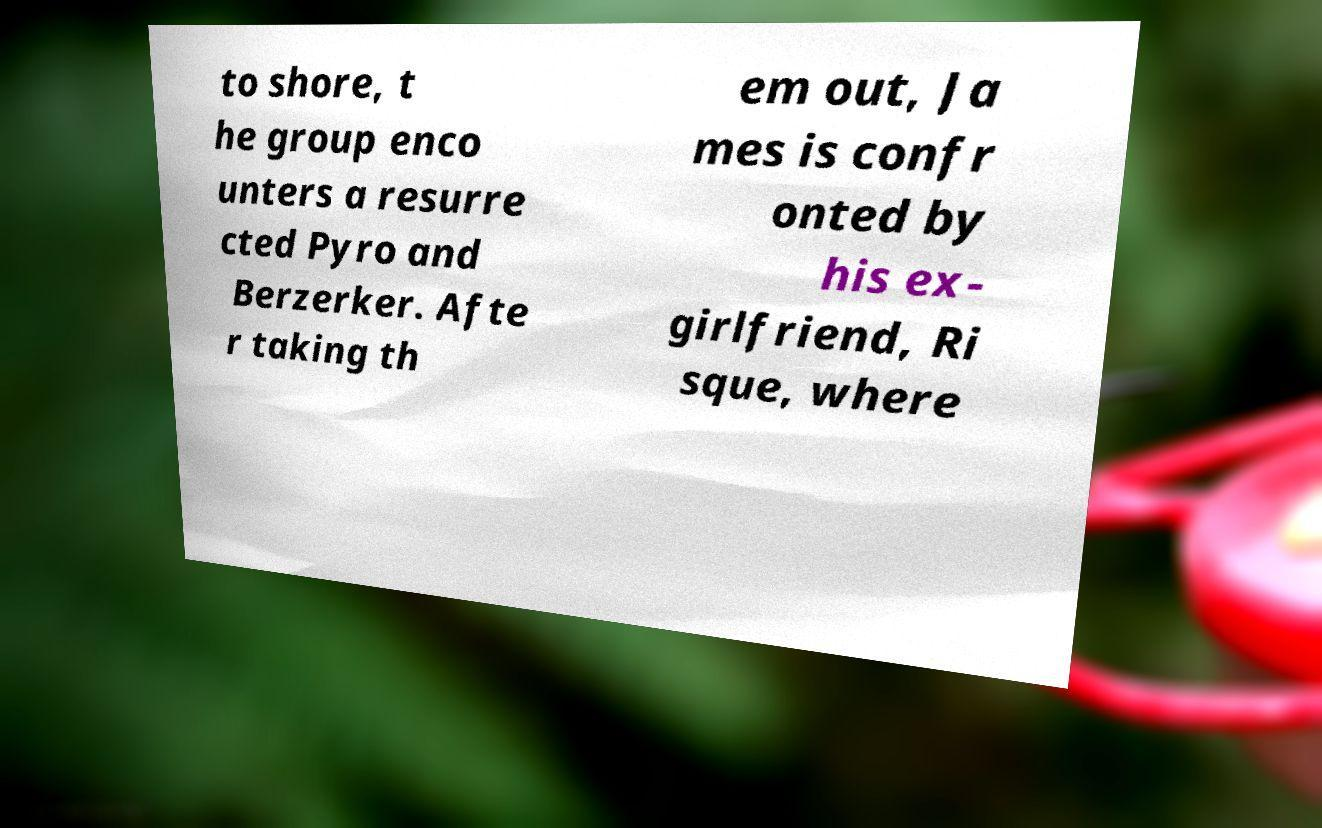For documentation purposes, I need the text within this image transcribed. Could you provide that? to shore, t he group enco unters a resurre cted Pyro and Berzerker. Afte r taking th em out, Ja mes is confr onted by his ex- girlfriend, Ri sque, where 